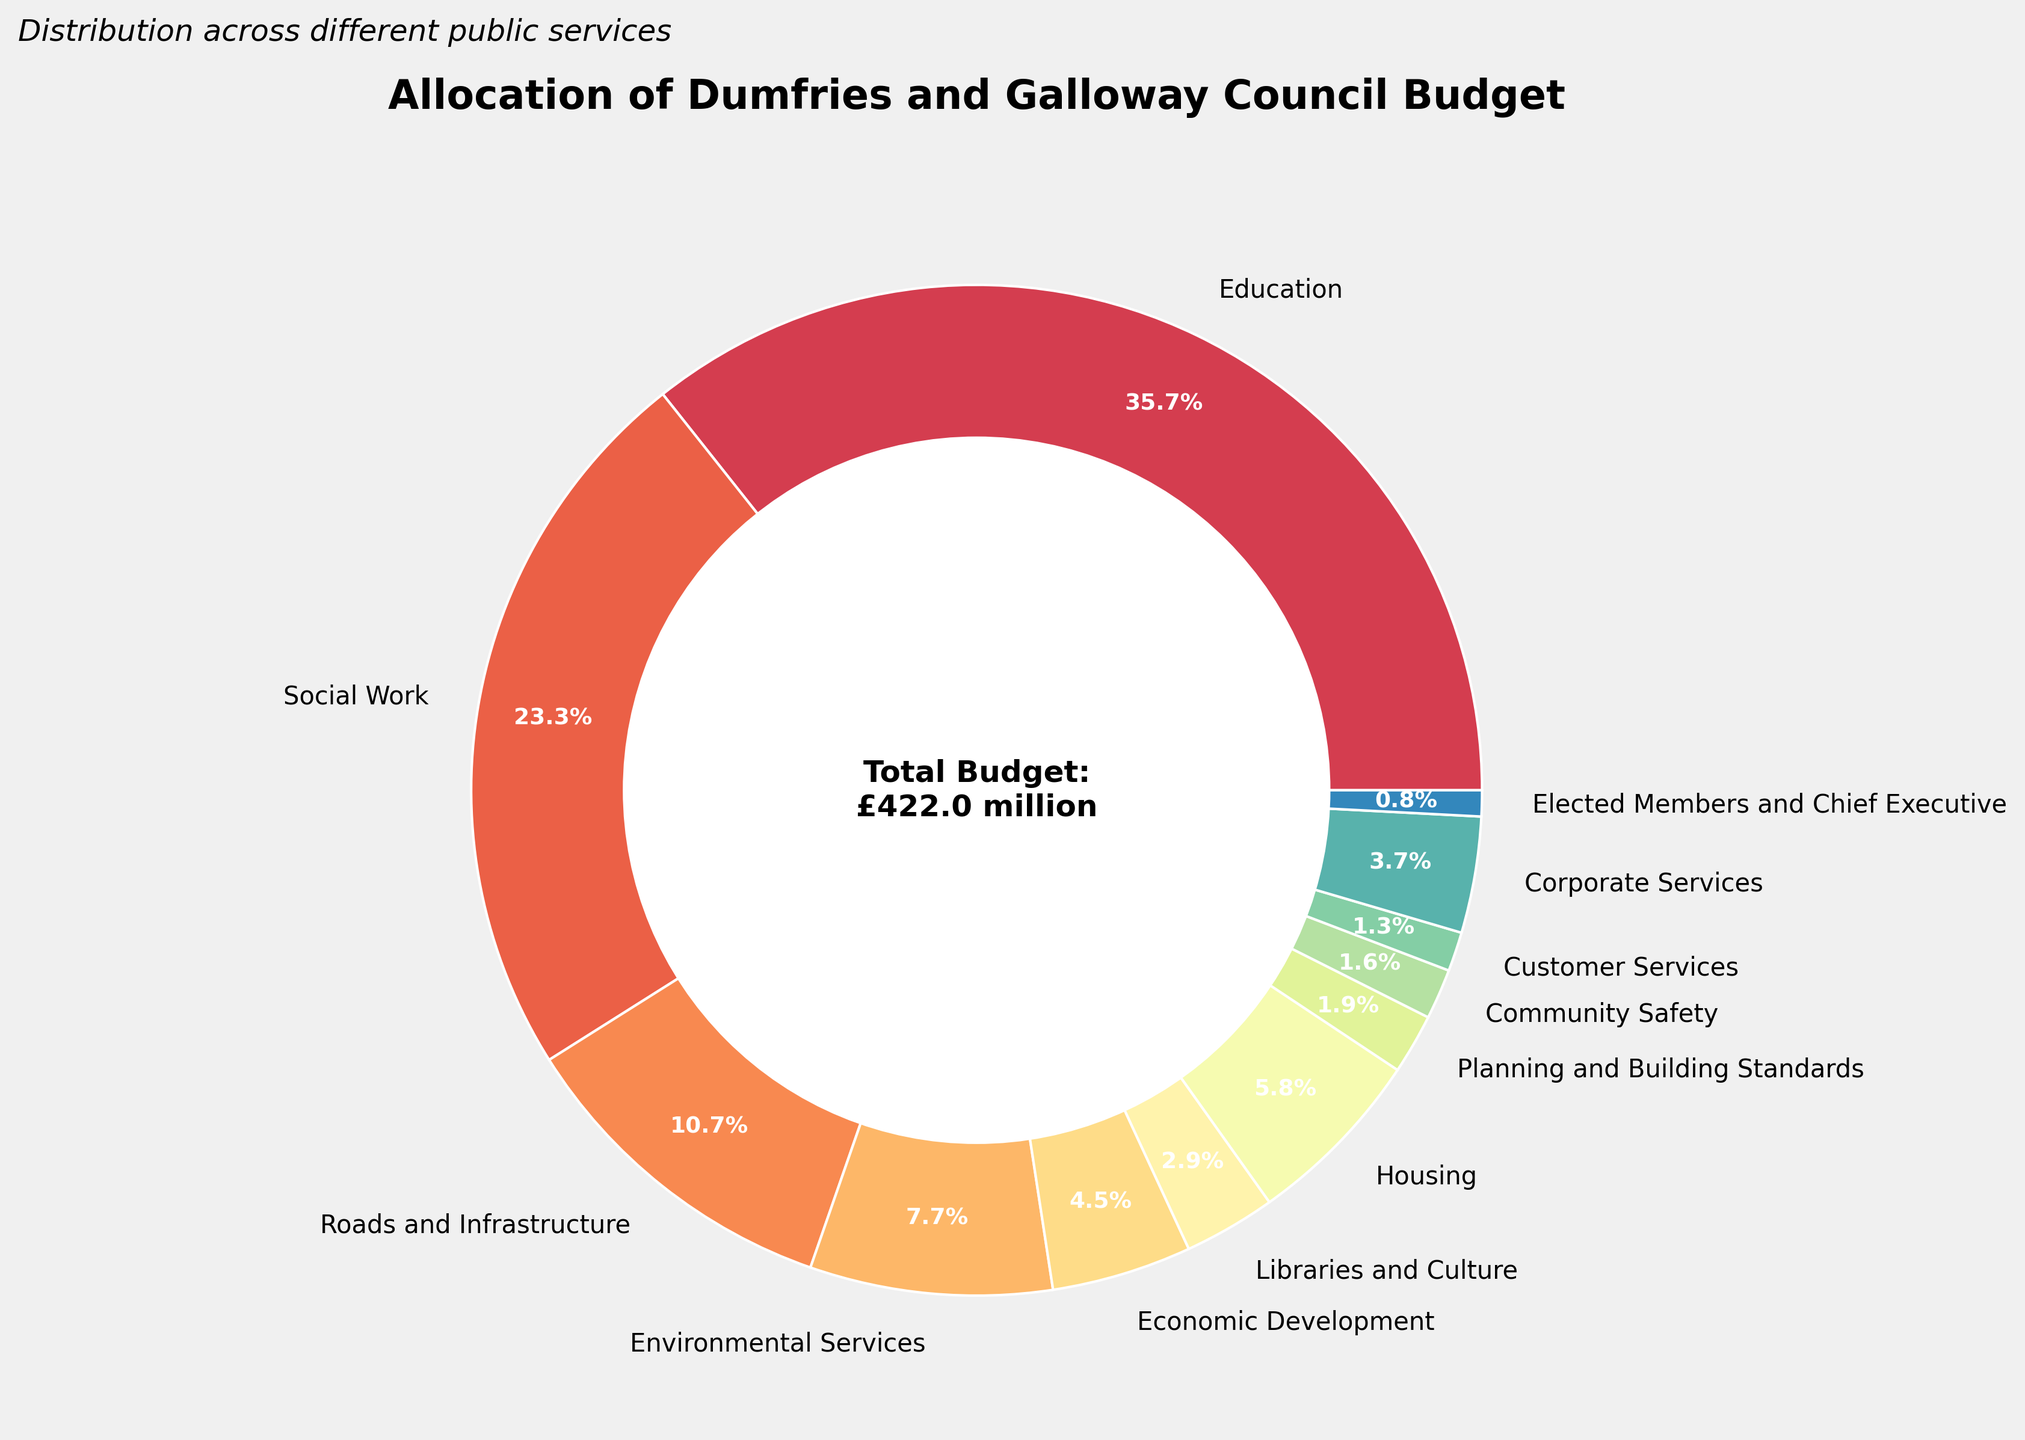What percentage of the total budget is allocated to Education? The pie chart shows that Education has been allocated 150.5 million out of the total budget. The total budget is the sum of all allocations, which is 421 million. To calculate the percentage, divide 150.5 by 421 and then multiply by 100: (150.5 / 421) * 100 ≈ 35.7%.
Answer: 35.7% Which service has the smallest budget allocation, and what is the amount? By looking at the pie chart, the service with the smallest wedge, indicating the smallest budget, is "Elected Members and Chief Executive," with an allocation of 3.5 million.
Answer: Elected Members and Chief Executive, 3.5 million How does the budget for Social Work compare to the budget for Roads and Infrastructure? Social Work has been allocated 98.3 million, while Roads and Infrastructure has been allocated 45.2 million. Social Work's budget can be compared to Roads and Infrastructure by subtraction: 98.3 - 45.2 = 53.1 million more for Social Work.
Answer: Social Work has 53.1 million more than Roads and Infrastructure What is the combined budget for Libraries and Culture and Economic Development? Libraries and Culture is allocated 12.4 million, and Economic Development is allocated 18.9 million. Adding these together gives: 12.4 + 18.9 = 31.3 million.
Answer: 31.3 million If the council decides to increase the budget for Housing by 10% without changing the total budget, by how much will they need to reduce the other allocations? The current budget for Housing is 24.6 million. Increasing by 10% means 24.6 * 0.1 = 2.46 million. To keep the total budget unchanged, they would need to reduce the other allocations by a total of 2.46 million.
Answer: 2.46 million What fraction of the total budget is allocated to Customer Services? Customer Services is allocated 5.3 million out of the total budget of 421 million. The fraction is 5.3 / 421. Simplifying this results in approximately 1/79.
Answer: 1/79 What is the difference in allocation between Corporate Services and Environmental Services? Corporate Services has a budget of 15.7 million, and Environmental Services has a budget of 32.7 million. The difference is calculated as: 32.7 - 15.7 = 17 million.
Answer: 17 million Out of Corporate Services, Planning and Building Standards, and Community Safety, which has the highest allocation? Corporate Services is allocated 15.7 million, Planning and Building Standards is 8.1 million, and Community Safety is 6.8 million. Comparing these, Corporate Services has the highest allocation.
Answer: Corporate Services Calculate the median value of the budget allocations. Sort the budget allocations in ascending order: 3.5, 5.3, 6.8, 8.1, 12.4, 15.7, 18.9, 24.6, 32.7, 45.2, 98.3, 150.5. The median value, being the middle value in this sorted list, is the average of the 6th and 7th values: (15.7 + 18.9) / 2 = 17.3 million.
Answer: 17.3 million What is the total budget for services that have more than 20 million allocation? Services with more than 20 million allocation are Education (150.5 million), Social Work (98.3 million), and Roads and Infrastructure (45.2 million). Summing these values gives: 150.5 + 98.3 + 45.2 = 294 million.
Answer: 294 million 